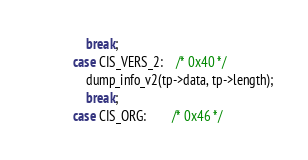Convert code to text. <code><loc_0><loc_0><loc_500><loc_500><_C_>				break;
			case CIS_VERS_2:	/* 0x40 */
				dump_info_v2(tp->data, tp->length);
				break;
			case CIS_ORG:		/* 0x46 */</code> 